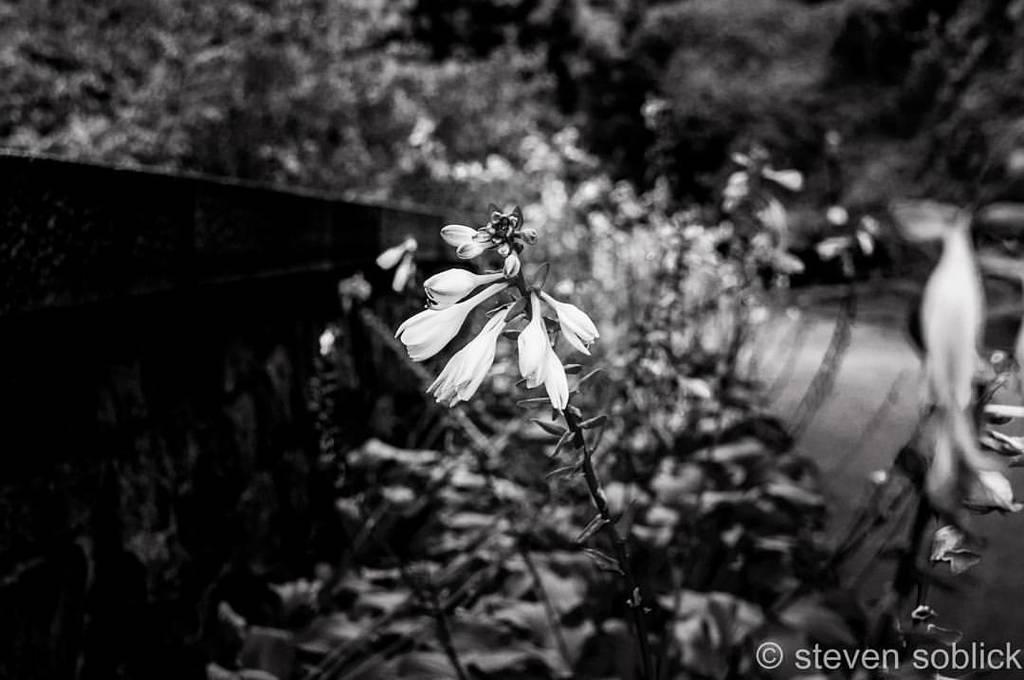Describe this image in one or two sentences. On the bottom left, there is a watermark. In the middle of the image, there is a plant having flowers. And the background is blurred. 